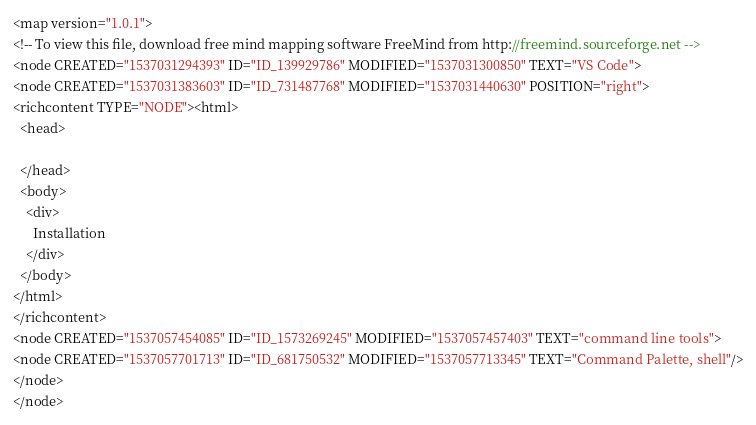<code> <loc_0><loc_0><loc_500><loc_500><_ObjectiveC_><map version="1.0.1">
<!-- To view this file, download free mind mapping software FreeMind from http://freemind.sourceforge.net -->
<node CREATED="1537031294393" ID="ID_139929786" MODIFIED="1537031300850" TEXT="VS Code">
<node CREATED="1537031383603" ID="ID_731487768" MODIFIED="1537031440630" POSITION="right">
<richcontent TYPE="NODE"><html>
  <head>
    
  </head>
  <body>
    <div>
      Installation
    </div>
  </body>
</html>
</richcontent>
<node CREATED="1537057454085" ID="ID_1573269245" MODIFIED="1537057457403" TEXT="command line tools">
<node CREATED="1537057701713" ID="ID_681750532" MODIFIED="1537057713345" TEXT="Command Palette, shell"/>
</node>
</node></code> 